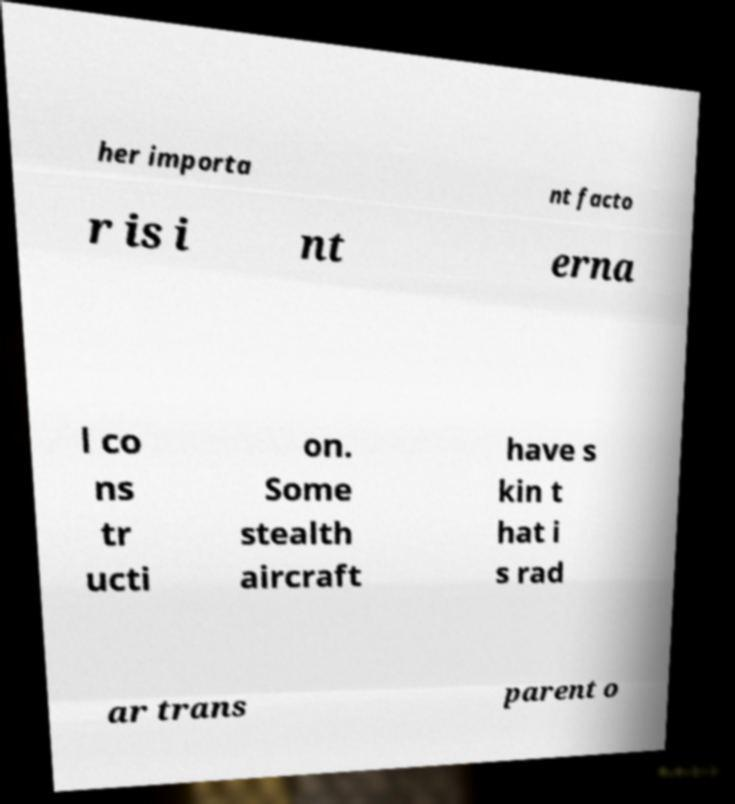Please identify and transcribe the text found in this image. her importa nt facto r is i nt erna l co ns tr ucti on. Some stealth aircraft have s kin t hat i s rad ar trans parent o 